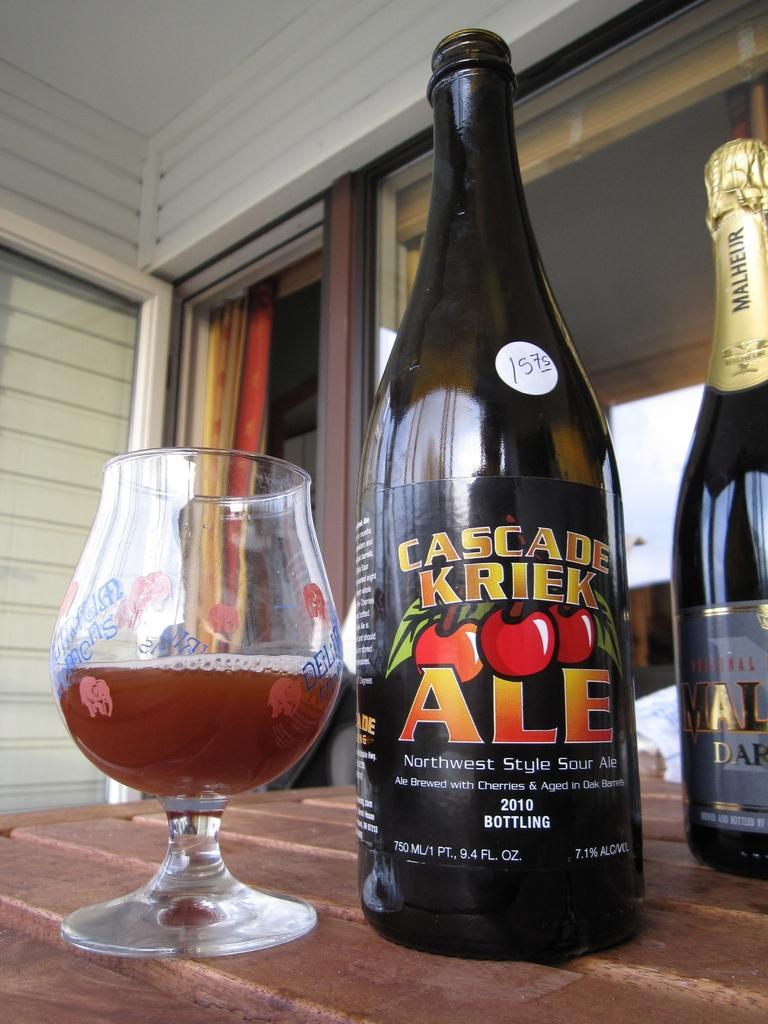<image>
Render a clear and concise summary of the photo. A bottle of Cascade Kriek Ale is on top of a table next to a half full glass. 